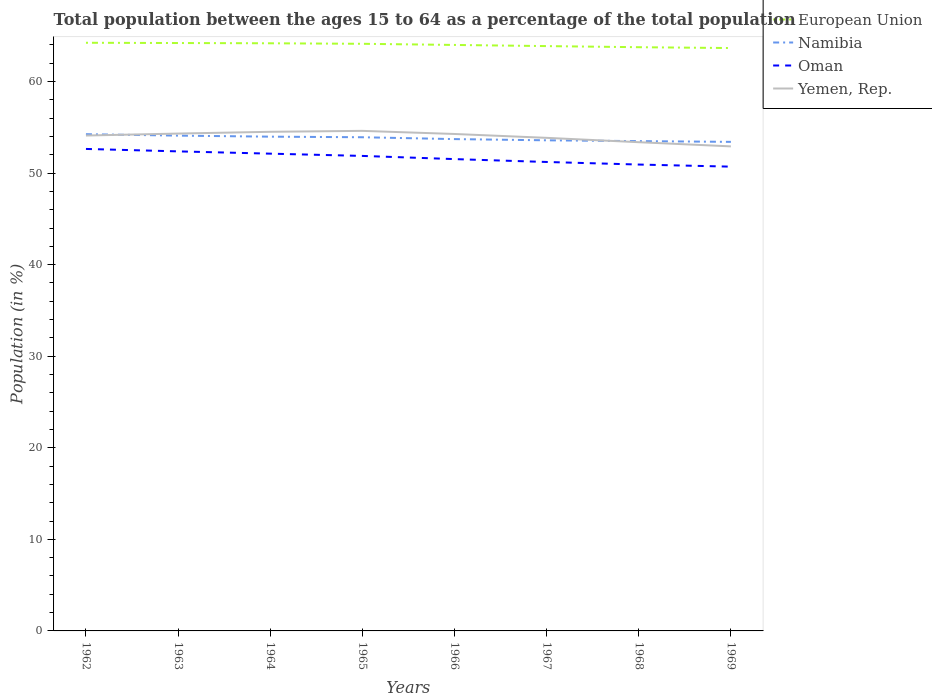How many different coloured lines are there?
Keep it short and to the point. 4. Does the line corresponding to Oman intersect with the line corresponding to Yemen, Rep.?
Make the answer very short. No. Across all years, what is the maximum percentage of the population ages 15 to 64 in Yemen, Rep.?
Your response must be concise. 52.91. In which year was the percentage of the population ages 15 to 64 in Yemen, Rep. maximum?
Offer a very short reply. 1969. What is the total percentage of the population ages 15 to 64 in Yemen, Rep. in the graph?
Your answer should be compact. 1.24. What is the difference between the highest and the second highest percentage of the population ages 15 to 64 in Namibia?
Make the answer very short. 0.84. How many lines are there?
Give a very brief answer. 4. How many years are there in the graph?
Your answer should be very brief. 8. Are the values on the major ticks of Y-axis written in scientific E-notation?
Your response must be concise. No. What is the title of the graph?
Provide a succinct answer. Total population between the ages 15 to 64 as a percentage of the total population. What is the Population (in %) of European Union in 1962?
Your answer should be compact. 64.23. What is the Population (in %) in Namibia in 1962?
Keep it short and to the point. 54.25. What is the Population (in %) of Oman in 1962?
Offer a terse response. 52.63. What is the Population (in %) in Yemen, Rep. in 1962?
Offer a terse response. 54.1. What is the Population (in %) in European Union in 1963?
Keep it short and to the point. 64.2. What is the Population (in %) in Namibia in 1963?
Your response must be concise. 54.09. What is the Population (in %) of Oman in 1963?
Ensure brevity in your answer.  52.37. What is the Population (in %) of Yemen, Rep. in 1963?
Your response must be concise. 54.31. What is the Population (in %) of European Union in 1964?
Your answer should be compact. 64.17. What is the Population (in %) in Namibia in 1964?
Your answer should be very brief. 53.97. What is the Population (in %) of Oman in 1964?
Provide a succinct answer. 52.12. What is the Population (in %) in Yemen, Rep. in 1964?
Your response must be concise. 54.51. What is the Population (in %) of European Union in 1965?
Offer a terse response. 64.12. What is the Population (in %) in Namibia in 1965?
Your answer should be very brief. 53.91. What is the Population (in %) in Oman in 1965?
Offer a terse response. 51.87. What is the Population (in %) in Yemen, Rep. in 1965?
Offer a very short reply. 54.61. What is the Population (in %) of European Union in 1966?
Provide a succinct answer. 63.99. What is the Population (in %) in Namibia in 1966?
Offer a very short reply. 53.71. What is the Population (in %) of Oman in 1966?
Keep it short and to the point. 51.52. What is the Population (in %) in Yemen, Rep. in 1966?
Give a very brief answer. 54.27. What is the Population (in %) in European Union in 1967?
Offer a terse response. 63.86. What is the Population (in %) in Namibia in 1967?
Keep it short and to the point. 53.58. What is the Population (in %) in Oman in 1967?
Provide a short and direct response. 51.21. What is the Population (in %) of Yemen, Rep. in 1967?
Provide a short and direct response. 53.85. What is the Population (in %) in European Union in 1968?
Your answer should be very brief. 63.74. What is the Population (in %) of Namibia in 1968?
Your answer should be very brief. 53.49. What is the Population (in %) in Oman in 1968?
Keep it short and to the point. 50.93. What is the Population (in %) of Yemen, Rep. in 1968?
Offer a very short reply. 53.37. What is the Population (in %) of European Union in 1969?
Provide a short and direct response. 63.65. What is the Population (in %) of Namibia in 1969?
Make the answer very short. 53.41. What is the Population (in %) in Oman in 1969?
Your answer should be very brief. 50.7. What is the Population (in %) in Yemen, Rep. in 1969?
Provide a short and direct response. 52.91. Across all years, what is the maximum Population (in %) in European Union?
Make the answer very short. 64.23. Across all years, what is the maximum Population (in %) of Namibia?
Provide a succinct answer. 54.25. Across all years, what is the maximum Population (in %) in Oman?
Give a very brief answer. 52.63. Across all years, what is the maximum Population (in %) in Yemen, Rep.?
Offer a very short reply. 54.61. Across all years, what is the minimum Population (in %) in European Union?
Offer a very short reply. 63.65. Across all years, what is the minimum Population (in %) of Namibia?
Give a very brief answer. 53.41. Across all years, what is the minimum Population (in %) of Oman?
Provide a succinct answer. 50.7. Across all years, what is the minimum Population (in %) in Yemen, Rep.?
Offer a very short reply. 52.91. What is the total Population (in %) of European Union in the graph?
Provide a short and direct response. 511.96. What is the total Population (in %) of Namibia in the graph?
Your answer should be compact. 430.4. What is the total Population (in %) in Oman in the graph?
Keep it short and to the point. 413.36. What is the total Population (in %) of Yemen, Rep. in the graph?
Your answer should be very brief. 431.92. What is the difference between the Population (in %) in European Union in 1962 and that in 1963?
Make the answer very short. 0.03. What is the difference between the Population (in %) in Namibia in 1962 and that in 1963?
Offer a terse response. 0.16. What is the difference between the Population (in %) of Oman in 1962 and that in 1963?
Your answer should be compact. 0.27. What is the difference between the Population (in %) in Yemen, Rep. in 1962 and that in 1963?
Keep it short and to the point. -0.21. What is the difference between the Population (in %) of European Union in 1962 and that in 1964?
Your answer should be very brief. 0.06. What is the difference between the Population (in %) of Namibia in 1962 and that in 1964?
Your response must be concise. 0.27. What is the difference between the Population (in %) of Oman in 1962 and that in 1964?
Give a very brief answer. 0.52. What is the difference between the Population (in %) in Yemen, Rep. in 1962 and that in 1964?
Your answer should be very brief. -0.41. What is the difference between the Population (in %) of European Union in 1962 and that in 1965?
Ensure brevity in your answer.  0.11. What is the difference between the Population (in %) in Namibia in 1962 and that in 1965?
Keep it short and to the point. 0.33. What is the difference between the Population (in %) of Oman in 1962 and that in 1965?
Keep it short and to the point. 0.76. What is the difference between the Population (in %) of Yemen, Rep. in 1962 and that in 1965?
Offer a terse response. -0.51. What is the difference between the Population (in %) of European Union in 1962 and that in 1966?
Provide a short and direct response. 0.24. What is the difference between the Population (in %) of Namibia in 1962 and that in 1966?
Provide a succinct answer. 0.54. What is the difference between the Population (in %) of Oman in 1962 and that in 1966?
Give a very brief answer. 1.11. What is the difference between the Population (in %) in Yemen, Rep. in 1962 and that in 1966?
Ensure brevity in your answer.  -0.17. What is the difference between the Population (in %) in European Union in 1962 and that in 1967?
Make the answer very short. 0.36. What is the difference between the Population (in %) of Namibia in 1962 and that in 1967?
Give a very brief answer. 0.67. What is the difference between the Population (in %) in Oman in 1962 and that in 1967?
Give a very brief answer. 1.42. What is the difference between the Population (in %) of Yemen, Rep. in 1962 and that in 1967?
Your answer should be compact. 0.25. What is the difference between the Population (in %) in European Union in 1962 and that in 1968?
Your response must be concise. 0.48. What is the difference between the Population (in %) in Namibia in 1962 and that in 1968?
Your answer should be very brief. 0.76. What is the difference between the Population (in %) of Oman in 1962 and that in 1968?
Provide a succinct answer. 1.7. What is the difference between the Population (in %) in Yemen, Rep. in 1962 and that in 1968?
Your response must be concise. 0.73. What is the difference between the Population (in %) in European Union in 1962 and that in 1969?
Give a very brief answer. 0.58. What is the difference between the Population (in %) in Namibia in 1962 and that in 1969?
Your answer should be very brief. 0.84. What is the difference between the Population (in %) of Oman in 1962 and that in 1969?
Provide a succinct answer. 1.93. What is the difference between the Population (in %) in Yemen, Rep. in 1962 and that in 1969?
Offer a very short reply. 1.18. What is the difference between the Population (in %) of European Union in 1963 and that in 1964?
Provide a succinct answer. 0.03. What is the difference between the Population (in %) in Namibia in 1963 and that in 1964?
Your answer should be compact. 0.11. What is the difference between the Population (in %) in Oman in 1963 and that in 1964?
Your answer should be very brief. 0.25. What is the difference between the Population (in %) of Yemen, Rep. in 1963 and that in 1964?
Your response must be concise. -0.19. What is the difference between the Population (in %) in European Union in 1963 and that in 1965?
Provide a succinct answer. 0.08. What is the difference between the Population (in %) in Namibia in 1963 and that in 1965?
Provide a short and direct response. 0.18. What is the difference between the Population (in %) of Oman in 1963 and that in 1965?
Offer a terse response. 0.5. What is the difference between the Population (in %) in Yemen, Rep. in 1963 and that in 1965?
Your response must be concise. -0.3. What is the difference between the Population (in %) of European Union in 1963 and that in 1966?
Keep it short and to the point. 0.21. What is the difference between the Population (in %) in Namibia in 1963 and that in 1966?
Keep it short and to the point. 0.38. What is the difference between the Population (in %) of Oman in 1963 and that in 1966?
Keep it short and to the point. 0.84. What is the difference between the Population (in %) of Yemen, Rep. in 1963 and that in 1966?
Provide a short and direct response. 0.04. What is the difference between the Population (in %) of European Union in 1963 and that in 1967?
Provide a succinct answer. 0.34. What is the difference between the Population (in %) of Namibia in 1963 and that in 1967?
Keep it short and to the point. 0.51. What is the difference between the Population (in %) of Oman in 1963 and that in 1967?
Give a very brief answer. 1.16. What is the difference between the Population (in %) of Yemen, Rep. in 1963 and that in 1967?
Give a very brief answer. 0.47. What is the difference between the Population (in %) of European Union in 1963 and that in 1968?
Give a very brief answer. 0.46. What is the difference between the Population (in %) of Namibia in 1963 and that in 1968?
Your answer should be very brief. 0.6. What is the difference between the Population (in %) of Oman in 1963 and that in 1968?
Provide a succinct answer. 1.44. What is the difference between the Population (in %) in Yemen, Rep. in 1963 and that in 1968?
Give a very brief answer. 0.94. What is the difference between the Population (in %) in European Union in 1963 and that in 1969?
Your answer should be compact. 0.55. What is the difference between the Population (in %) in Namibia in 1963 and that in 1969?
Provide a short and direct response. 0.68. What is the difference between the Population (in %) in Oman in 1963 and that in 1969?
Offer a terse response. 1.67. What is the difference between the Population (in %) of Yemen, Rep. in 1963 and that in 1969?
Offer a very short reply. 1.4. What is the difference between the Population (in %) in European Union in 1964 and that in 1965?
Offer a very short reply. 0.06. What is the difference between the Population (in %) of Namibia in 1964 and that in 1965?
Provide a short and direct response. 0.06. What is the difference between the Population (in %) of Oman in 1964 and that in 1965?
Offer a terse response. 0.25. What is the difference between the Population (in %) of Yemen, Rep. in 1964 and that in 1965?
Your answer should be very brief. -0.1. What is the difference between the Population (in %) of European Union in 1964 and that in 1966?
Provide a succinct answer. 0.18. What is the difference between the Population (in %) in Namibia in 1964 and that in 1966?
Keep it short and to the point. 0.27. What is the difference between the Population (in %) of Oman in 1964 and that in 1966?
Make the answer very short. 0.59. What is the difference between the Population (in %) of Yemen, Rep. in 1964 and that in 1966?
Give a very brief answer. 0.24. What is the difference between the Population (in %) of European Union in 1964 and that in 1967?
Your answer should be very brief. 0.31. What is the difference between the Population (in %) in Namibia in 1964 and that in 1967?
Provide a succinct answer. 0.4. What is the difference between the Population (in %) in Oman in 1964 and that in 1967?
Offer a very short reply. 0.91. What is the difference between the Population (in %) of Yemen, Rep. in 1964 and that in 1967?
Provide a succinct answer. 0.66. What is the difference between the Population (in %) in European Union in 1964 and that in 1968?
Provide a succinct answer. 0.43. What is the difference between the Population (in %) in Namibia in 1964 and that in 1968?
Your response must be concise. 0.49. What is the difference between the Population (in %) in Oman in 1964 and that in 1968?
Keep it short and to the point. 1.19. What is the difference between the Population (in %) in Yemen, Rep. in 1964 and that in 1968?
Give a very brief answer. 1.14. What is the difference between the Population (in %) of European Union in 1964 and that in 1969?
Your answer should be very brief. 0.52. What is the difference between the Population (in %) of Namibia in 1964 and that in 1969?
Give a very brief answer. 0.57. What is the difference between the Population (in %) in Oman in 1964 and that in 1969?
Provide a short and direct response. 1.42. What is the difference between the Population (in %) of Yemen, Rep. in 1964 and that in 1969?
Your answer should be very brief. 1.59. What is the difference between the Population (in %) of European Union in 1965 and that in 1966?
Your answer should be very brief. 0.12. What is the difference between the Population (in %) of Namibia in 1965 and that in 1966?
Your response must be concise. 0.2. What is the difference between the Population (in %) of Oman in 1965 and that in 1966?
Give a very brief answer. 0.35. What is the difference between the Population (in %) of Yemen, Rep. in 1965 and that in 1966?
Offer a terse response. 0.34. What is the difference between the Population (in %) in European Union in 1965 and that in 1967?
Offer a very short reply. 0.25. What is the difference between the Population (in %) of Namibia in 1965 and that in 1967?
Give a very brief answer. 0.33. What is the difference between the Population (in %) in Oman in 1965 and that in 1967?
Your answer should be very brief. 0.66. What is the difference between the Population (in %) in Yemen, Rep. in 1965 and that in 1967?
Your answer should be compact. 0.76. What is the difference between the Population (in %) in European Union in 1965 and that in 1968?
Offer a terse response. 0.37. What is the difference between the Population (in %) in Namibia in 1965 and that in 1968?
Make the answer very short. 0.42. What is the difference between the Population (in %) in Oman in 1965 and that in 1968?
Keep it short and to the point. 0.94. What is the difference between the Population (in %) in Yemen, Rep. in 1965 and that in 1968?
Offer a terse response. 1.24. What is the difference between the Population (in %) of European Union in 1965 and that in 1969?
Give a very brief answer. 0.46. What is the difference between the Population (in %) of Namibia in 1965 and that in 1969?
Provide a short and direct response. 0.5. What is the difference between the Population (in %) in Oman in 1965 and that in 1969?
Give a very brief answer. 1.17. What is the difference between the Population (in %) of Yemen, Rep. in 1965 and that in 1969?
Your answer should be very brief. 1.69. What is the difference between the Population (in %) in European Union in 1966 and that in 1967?
Provide a short and direct response. 0.13. What is the difference between the Population (in %) of Namibia in 1966 and that in 1967?
Keep it short and to the point. 0.13. What is the difference between the Population (in %) of Oman in 1966 and that in 1967?
Offer a very short reply. 0.31. What is the difference between the Population (in %) in Yemen, Rep. in 1966 and that in 1967?
Give a very brief answer. 0.42. What is the difference between the Population (in %) in European Union in 1966 and that in 1968?
Keep it short and to the point. 0.25. What is the difference between the Population (in %) of Namibia in 1966 and that in 1968?
Your response must be concise. 0.22. What is the difference between the Population (in %) in Oman in 1966 and that in 1968?
Your response must be concise. 0.59. What is the difference between the Population (in %) of Yemen, Rep. in 1966 and that in 1968?
Your answer should be compact. 0.9. What is the difference between the Population (in %) of European Union in 1966 and that in 1969?
Your answer should be compact. 0.34. What is the difference between the Population (in %) in Namibia in 1966 and that in 1969?
Provide a succinct answer. 0.3. What is the difference between the Population (in %) in Oman in 1966 and that in 1969?
Your answer should be compact. 0.82. What is the difference between the Population (in %) in Yemen, Rep. in 1966 and that in 1969?
Your answer should be compact. 1.35. What is the difference between the Population (in %) of European Union in 1967 and that in 1968?
Provide a short and direct response. 0.12. What is the difference between the Population (in %) in Namibia in 1967 and that in 1968?
Make the answer very short. 0.09. What is the difference between the Population (in %) in Oman in 1967 and that in 1968?
Offer a very short reply. 0.28. What is the difference between the Population (in %) in Yemen, Rep. in 1967 and that in 1968?
Your answer should be very brief. 0.48. What is the difference between the Population (in %) of European Union in 1967 and that in 1969?
Your response must be concise. 0.21. What is the difference between the Population (in %) in Namibia in 1967 and that in 1969?
Offer a terse response. 0.17. What is the difference between the Population (in %) in Oman in 1967 and that in 1969?
Make the answer very short. 0.51. What is the difference between the Population (in %) of Yemen, Rep. in 1967 and that in 1969?
Keep it short and to the point. 0.93. What is the difference between the Population (in %) of European Union in 1968 and that in 1969?
Provide a succinct answer. 0.09. What is the difference between the Population (in %) of Namibia in 1968 and that in 1969?
Offer a terse response. 0.08. What is the difference between the Population (in %) of Oman in 1968 and that in 1969?
Keep it short and to the point. 0.23. What is the difference between the Population (in %) in Yemen, Rep. in 1968 and that in 1969?
Your response must be concise. 0.46. What is the difference between the Population (in %) in European Union in 1962 and the Population (in %) in Namibia in 1963?
Ensure brevity in your answer.  10.14. What is the difference between the Population (in %) of European Union in 1962 and the Population (in %) of Oman in 1963?
Your response must be concise. 11.86. What is the difference between the Population (in %) in European Union in 1962 and the Population (in %) in Yemen, Rep. in 1963?
Offer a terse response. 9.92. What is the difference between the Population (in %) in Namibia in 1962 and the Population (in %) in Oman in 1963?
Provide a succinct answer. 1.88. What is the difference between the Population (in %) in Namibia in 1962 and the Population (in %) in Yemen, Rep. in 1963?
Your answer should be compact. -0.07. What is the difference between the Population (in %) of Oman in 1962 and the Population (in %) of Yemen, Rep. in 1963?
Offer a terse response. -1.68. What is the difference between the Population (in %) of European Union in 1962 and the Population (in %) of Namibia in 1964?
Keep it short and to the point. 10.25. What is the difference between the Population (in %) of European Union in 1962 and the Population (in %) of Oman in 1964?
Provide a short and direct response. 12.11. What is the difference between the Population (in %) in European Union in 1962 and the Population (in %) in Yemen, Rep. in 1964?
Provide a succinct answer. 9.72. What is the difference between the Population (in %) in Namibia in 1962 and the Population (in %) in Oman in 1964?
Your answer should be compact. 2.13. What is the difference between the Population (in %) in Namibia in 1962 and the Population (in %) in Yemen, Rep. in 1964?
Provide a short and direct response. -0.26. What is the difference between the Population (in %) of Oman in 1962 and the Population (in %) of Yemen, Rep. in 1964?
Provide a short and direct response. -1.87. What is the difference between the Population (in %) of European Union in 1962 and the Population (in %) of Namibia in 1965?
Provide a succinct answer. 10.32. What is the difference between the Population (in %) in European Union in 1962 and the Population (in %) in Oman in 1965?
Your response must be concise. 12.36. What is the difference between the Population (in %) of European Union in 1962 and the Population (in %) of Yemen, Rep. in 1965?
Ensure brevity in your answer.  9.62. What is the difference between the Population (in %) in Namibia in 1962 and the Population (in %) in Oman in 1965?
Ensure brevity in your answer.  2.37. What is the difference between the Population (in %) of Namibia in 1962 and the Population (in %) of Yemen, Rep. in 1965?
Your answer should be compact. -0.36. What is the difference between the Population (in %) of Oman in 1962 and the Population (in %) of Yemen, Rep. in 1965?
Your answer should be compact. -1.97. What is the difference between the Population (in %) in European Union in 1962 and the Population (in %) in Namibia in 1966?
Give a very brief answer. 10.52. What is the difference between the Population (in %) of European Union in 1962 and the Population (in %) of Oman in 1966?
Provide a short and direct response. 12.7. What is the difference between the Population (in %) of European Union in 1962 and the Population (in %) of Yemen, Rep. in 1966?
Give a very brief answer. 9.96. What is the difference between the Population (in %) of Namibia in 1962 and the Population (in %) of Oman in 1966?
Give a very brief answer. 2.72. What is the difference between the Population (in %) in Namibia in 1962 and the Population (in %) in Yemen, Rep. in 1966?
Your answer should be compact. -0.02. What is the difference between the Population (in %) in Oman in 1962 and the Population (in %) in Yemen, Rep. in 1966?
Your response must be concise. -1.63. What is the difference between the Population (in %) in European Union in 1962 and the Population (in %) in Namibia in 1967?
Provide a short and direct response. 10.65. What is the difference between the Population (in %) in European Union in 1962 and the Population (in %) in Oman in 1967?
Give a very brief answer. 13.02. What is the difference between the Population (in %) of European Union in 1962 and the Population (in %) of Yemen, Rep. in 1967?
Keep it short and to the point. 10.38. What is the difference between the Population (in %) in Namibia in 1962 and the Population (in %) in Oman in 1967?
Offer a terse response. 3.04. What is the difference between the Population (in %) in Namibia in 1962 and the Population (in %) in Yemen, Rep. in 1967?
Keep it short and to the point. 0.4. What is the difference between the Population (in %) in Oman in 1962 and the Population (in %) in Yemen, Rep. in 1967?
Ensure brevity in your answer.  -1.21. What is the difference between the Population (in %) of European Union in 1962 and the Population (in %) of Namibia in 1968?
Your answer should be compact. 10.74. What is the difference between the Population (in %) in European Union in 1962 and the Population (in %) in Oman in 1968?
Make the answer very short. 13.3. What is the difference between the Population (in %) in European Union in 1962 and the Population (in %) in Yemen, Rep. in 1968?
Your response must be concise. 10.86. What is the difference between the Population (in %) of Namibia in 1962 and the Population (in %) of Oman in 1968?
Provide a short and direct response. 3.32. What is the difference between the Population (in %) of Namibia in 1962 and the Population (in %) of Yemen, Rep. in 1968?
Provide a short and direct response. 0.88. What is the difference between the Population (in %) in Oman in 1962 and the Population (in %) in Yemen, Rep. in 1968?
Keep it short and to the point. -0.74. What is the difference between the Population (in %) in European Union in 1962 and the Population (in %) in Namibia in 1969?
Provide a succinct answer. 10.82. What is the difference between the Population (in %) of European Union in 1962 and the Population (in %) of Oman in 1969?
Your answer should be compact. 13.53. What is the difference between the Population (in %) of European Union in 1962 and the Population (in %) of Yemen, Rep. in 1969?
Keep it short and to the point. 11.31. What is the difference between the Population (in %) of Namibia in 1962 and the Population (in %) of Oman in 1969?
Ensure brevity in your answer.  3.55. What is the difference between the Population (in %) of Namibia in 1962 and the Population (in %) of Yemen, Rep. in 1969?
Offer a very short reply. 1.33. What is the difference between the Population (in %) in Oman in 1962 and the Population (in %) in Yemen, Rep. in 1969?
Provide a short and direct response. -0.28. What is the difference between the Population (in %) of European Union in 1963 and the Population (in %) of Namibia in 1964?
Your answer should be compact. 10.23. What is the difference between the Population (in %) of European Union in 1963 and the Population (in %) of Oman in 1964?
Your response must be concise. 12.08. What is the difference between the Population (in %) of European Union in 1963 and the Population (in %) of Yemen, Rep. in 1964?
Give a very brief answer. 9.69. What is the difference between the Population (in %) of Namibia in 1963 and the Population (in %) of Oman in 1964?
Your response must be concise. 1.97. What is the difference between the Population (in %) of Namibia in 1963 and the Population (in %) of Yemen, Rep. in 1964?
Offer a very short reply. -0.42. What is the difference between the Population (in %) of Oman in 1963 and the Population (in %) of Yemen, Rep. in 1964?
Ensure brevity in your answer.  -2.14. What is the difference between the Population (in %) in European Union in 1963 and the Population (in %) in Namibia in 1965?
Ensure brevity in your answer.  10.29. What is the difference between the Population (in %) of European Union in 1963 and the Population (in %) of Oman in 1965?
Offer a terse response. 12.33. What is the difference between the Population (in %) in European Union in 1963 and the Population (in %) in Yemen, Rep. in 1965?
Ensure brevity in your answer.  9.59. What is the difference between the Population (in %) of Namibia in 1963 and the Population (in %) of Oman in 1965?
Offer a terse response. 2.22. What is the difference between the Population (in %) in Namibia in 1963 and the Population (in %) in Yemen, Rep. in 1965?
Give a very brief answer. -0.52. What is the difference between the Population (in %) of Oman in 1963 and the Population (in %) of Yemen, Rep. in 1965?
Keep it short and to the point. -2.24. What is the difference between the Population (in %) of European Union in 1963 and the Population (in %) of Namibia in 1966?
Your response must be concise. 10.49. What is the difference between the Population (in %) of European Union in 1963 and the Population (in %) of Oman in 1966?
Your answer should be very brief. 12.68. What is the difference between the Population (in %) in European Union in 1963 and the Population (in %) in Yemen, Rep. in 1966?
Make the answer very short. 9.93. What is the difference between the Population (in %) of Namibia in 1963 and the Population (in %) of Oman in 1966?
Your response must be concise. 2.56. What is the difference between the Population (in %) of Namibia in 1963 and the Population (in %) of Yemen, Rep. in 1966?
Your response must be concise. -0.18. What is the difference between the Population (in %) in Oman in 1963 and the Population (in %) in Yemen, Rep. in 1966?
Make the answer very short. -1.9. What is the difference between the Population (in %) of European Union in 1963 and the Population (in %) of Namibia in 1967?
Provide a short and direct response. 10.62. What is the difference between the Population (in %) of European Union in 1963 and the Population (in %) of Oman in 1967?
Make the answer very short. 12.99. What is the difference between the Population (in %) of European Union in 1963 and the Population (in %) of Yemen, Rep. in 1967?
Provide a short and direct response. 10.35. What is the difference between the Population (in %) of Namibia in 1963 and the Population (in %) of Oman in 1967?
Offer a very short reply. 2.88. What is the difference between the Population (in %) in Namibia in 1963 and the Population (in %) in Yemen, Rep. in 1967?
Give a very brief answer. 0.24. What is the difference between the Population (in %) of Oman in 1963 and the Population (in %) of Yemen, Rep. in 1967?
Offer a terse response. -1.48. What is the difference between the Population (in %) of European Union in 1963 and the Population (in %) of Namibia in 1968?
Provide a short and direct response. 10.71. What is the difference between the Population (in %) of European Union in 1963 and the Population (in %) of Oman in 1968?
Your response must be concise. 13.27. What is the difference between the Population (in %) of European Union in 1963 and the Population (in %) of Yemen, Rep. in 1968?
Provide a succinct answer. 10.83. What is the difference between the Population (in %) of Namibia in 1963 and the Population (in %) of Oman in 1968?
Provide a succinct answer. 3.16. What is the difference between the Population (in %) in Namibia in 1963 and the Population (in %) in Yemen, Rep. in 1968?
Offer a very short reply. 0.72. What is the difference between the Population (in %) of Oman in 1963 and the Population (in %) of Yemen, Rep. in 1968?
Make the answer very short. -1. What is the difference between the Population (in %) in European Union in 1963 and the Population (in %) in Namibia in 1969?
Provide a succinct answer. 10.79. What is the difference between the Population (in %) of European Union in 1963 and the Population (in %) of Oman in 1969?
Your answer should be very brief. 13.5. What is the difference between the Population (in %) of European Union in 1963 and the Population (in %) of Yemen, Rep. in 1969?
Offer a very short reply. 11.29. What is the difference between the Population (in %) of Namibia in 1963 and the Population (in %) of Oman in 1969?
Your answer should be compact. 3.39. What is the difference between the Population (in %) in Namibia in 1963 and the Population (in %) in Yemen, Rep. in 1969?
Offer a very short reply. 1.17. What is the difference between the Population (in %) in Oman in 1963 and the Population (in %) in Yemen, Rep. in 1969?
Keep it short and to the point. -0.55. What is the difference between the Population (in %) in European Union in 1964 and the Population (in %) in Namibia in 1965?
Offer a terse response. 10.26. What is the difference between the Population (in %) of European Union in 1964 and the Population (in %) of Oman in 1965?
Offer a terse response. 12.3. What is the difference between the Population (in %) of European Union in 1964 and the Population (in %) of Yemen, Rep. in 1965?
Your answer should be very brief. 9.56. What is the difference between the Population (in %) of Namibia in 1964 and the Population (in %) of Oman in 1965?
Provide a short and direct response. 2.1. What is the difference between the Population (in %) in Namibia in 1964 and the Population (in %) in Yemen, Rep. in 1965?
Your response must be concise. -0.63. What is the difference between the Population (in %) of Oman in 1964 and the Population (in %) of Yemen, Rep. in 1965?
Offer a very short reply. -2.49. What is the difference between the Population (in %) in European Union in 1964 and the Population (in %) in Namibia in 1966?
Your answer should be compact. 10.46. What is the difference between the Population (in %) in European Union in 1964 and the Population (in %) in Oman in 1966?
Keep it short and to the point. 12.65. What is the difference between the Population (in %) in European Union in 1964 and the Population (in %) in Yemen, Rep. in 1966?
Give a very brief answer. 9.9. What is the difference between the Population (in %) in Namibia in 1964 and the Population (in %) in Oman in 1966?
Provide a short and direct response. 2.45. What is the difference between the Population (in %) of Namibia in 1964 and the Population (in %) of Yemen, Rep. in 1966?
Your answer should be very brief. -0.29. What is the difference between the Population (in %) in Oman in 1964 and the Population (in %) in Yemen, Rep. in 1966?
Your response must be concise. -2.15. What is the difference between the Population (in %) in European Union in 1964 and the Population (in %) in Namibia in 1967?
Keep it short and to the point. 10.6. What is the difference between the Population (in %) in European Union in 1964 and the Population (in %) in Oman in 1967?
Give a very brief answer. 12.96. What is the difference between the Population (in %) in European Union in 1964 and the Population (in %) in Yemen, Rep. in 1967?
Keep it short and to the point. 10.33. What is the difference between the Population (in %) of Namibia in 1964 and the Population (in %) of Oman in 1967?
Your answer should be compact. 2.76. What is the difference between the Population (in %) in Namibia in 1964 and the Population (in %) in Yemen, Rep. in 1967?
Provide a short and direct response. 0.13. What is the difference between the Population (in %) in Oman in 1964 and the Population (in %) in Yemen, Rep. in 1967?
Your response must be concise. -1.73. What is the difference between the Population (in %) of European Union in 1964 and the Population (in %) of Namibia in 1968?
Give a very brief answer. 10.68. What is the difference between the Population (in %) of European Union in 1964 and the Population (in %) of Oman in 1968?
Your response must be concise. 13.24. What is the difference between the Population (in %) in European Union in 1964 and the Population (in %) in Yemen, Rep. in 1968?
Ensure brevity in your answer.  10.8. What is the difference between the Population (in %) in Namibia in 1964 and the Population (in %) in Oman in 1968?
Give a very brief answer. 3.04. What is the difference between the Population (in %) in Namibia in 1964 and the Population (in %) in Yemen, Rep. in 1968?
Offer a very short reply. 0.6. What is the difference between the Population (in %) of Oman in 1964 and the Population (in %) of Yemen, Rep. in 1968?
Make the answer very short. -1.25. What is the difference between the Population (in %) in European Union in 1964 and the Population (in %) in Namibia in 1969?
Provide a succinct answer. 10.77. What is the difference between the Population (in %) of European Union in 1964 and the Population (in %) of Oman in 1969?
Your answer should be very brief. 13.47. What is the difference between the Population (in %) of European Union in 1964 and the Population (in %) of Yemen, Rep. in 1969?
Ensure brevity in your answer.  11.26. What is the difference between the Population (in %) in Namibia in 1964 and the Population (in %) in Oman in 1969?
Keep it short and to the point. 3.27. What is the difference between the Population (in %) in Namibia in 1964 and the Population (in %) in Yemen, Rep. in 1969?
Offer a terse response. 1.06. What is the difference between the Population (in %) in Oman in 1964 and the Population (in %) in Yemen, Rep. in 1969?
Your response must be concise. -0.8. What is the difference between the Population (in %) in European Union in 1965 and the Population (in %) in Namibia in 1966?
Your answer should be very brief. 10.41. What is the difference between the Population (in %) of European Union in 1965 and the Population (in %) of Oman in 1966?
Your answer should be very brief. 12.59. What is the difference between the Population (in %) in European Union in 1965 and the Population (in %) in Yemen, Rep. in 1966?
Give a very brief answer. 9.85. What is the difference between the Population (in %) of Namibia in 1965 and the Population (in %) of Oman in 1966?
Your response must be concise. 2.39. What is the difference between the Population (in %) of Namibia in 1965 and the Population (in %) of Yemen, Rep. in 1966?
Your response must be concise. -0.36. What is the difference between the Population (in %) in Oman in 1965 and the Population (in %) in Yemen, Rep. in 1966?
Keep it short and to the point. -2.4. What is the difference between the Population (in %) in European Union in 1965 and the Population (in %) in Namibia in 1967?
Offer a terse response. 10.54. What is the difference between the Population (in %) in European Union in 1965 and the Population (in %) in Oman in 1967?
Offer a terse response. 12.9. What is the difference between the Population (in %) of European Union in 1965 and the Population (in %) of Yemen, Rep. in 1967?
Give a very brief answer. 10.27. What is the difference between the Population (in %) of Namibia in 1965 and the Population (in %) of Oman in 1967?
Make the answer very short. 2.7. What is the difference between the Population (in %) in Namibia in 1965 and the Population (in %) in Yemen, Rep. in 1967?
Give a very brief answer. 0.06. What is the difference between the Population (in %) in Oman in 1965 and the Population (in %) in Yemen, Rep. in 1967?
Offer a terse response. -1.97. What is the difference between the Population (in %) in European Union in 1965 and the Population (in %) in Namibia in 1968?
Provide a succinct answer. 10.63. What is the difference between the Population (in %) of European Union in 1965 and the Population (in %) of Oman in 1968?
Offer a terse response. 13.19. What is the difference between the Population (in %) of European Union in 1965 and the Population (in %) of Yemen, Rep. in 1968?
Ensure brevity in your answer.  10.75. What is the difference between the Population (in %) in Namibia in 1965 and the Population (in %) in Oman in 1968?
Give a very brief answer. 2.98. What is the difference between the Population (in %) of Namibia in 1965 and the Population (in %) of Yemen, Rep. in 1968?
Provide a succinct answer. 0.54. What is the difference between the Population (in %) in Oman in 1965 and the Population (in %) in Yemen, Rep. in 1968?
Offer a terse response. -1.5. What is the difference between the Population (in %) in European Union in 1965 and the Population (in %) in Namibia in 1969?
Offer a very short reply. 10.71. What is the difference between the Population (in %) in European Union in 1965 and the Population (in %) in Oman in 1969?
Keep it short and to the point. 13.42. What is the difference between the Population (in %) in European Union in 1965 and the Population (in %) in Yemen, Rep. in 1969?
Keep it short and to the point. 11.2. What is the difference between the Population (in %) of Namibia in 1965 and the Population (in %) of Oman in 1969?
Offer a very short reply. 3.21. What is the difference between the Population (in %) of Oman in 1965 and the Population (in %) of Yemen, Rep. in 1969?
Ensure brevity in your answer.  -1.04. What is the difference between the Population (in %) of European Union in 1966 and the Population (in %) of Namibia in 1967?
Offer a very short reply. 10.41. What is the difference between the Population (in %) in European Union in 1966 and the Population (in %) in Oman in 1967?
Give a very brief answer. 12.78. What is the difference between the Population (in %) in European Union in 1966 and the Population (in %) in Yemen, Rep. in 1967?
Offer a terse response. 10.14. What is the difference between the Population (in %) in Namibia in 1966 and the Population (in %) in Oman in 1967?
Your response must be concise. 2.5. What is the difference between the Population (in %) of Namibia in 1966 and the Population (in %) of Yemen, Rep. in 1967?
Provide a succinct answer. -0.14. What is the difference between the Population (in %) of Oman in 1966 and the Population (in %) of Yemen, Rep. in 1967?
Make the answer very short. -2.32. What is the difference between the Population (in %) in European Union in 1966 and the Population (in %) in Namibia in 1968?
Make the answer very short. 10.5. What is the difference between the Population (in %) of European Union in 1966 and the Population (in %) of Oman in 1968?
Make the answer very short. 13.06. What is the difference between the Population (in %) of European Union in 1966 and the Population (in %) of Yemen, Rep. in 1968?
Ensure brevity in your answer.  10.62. What is the difference between the Population (in %) of Namibia in 1966 and the Population (in %) of Oman in 1968?
Make the answer very short. 2.78. What is the difference between the Population (in %) of Namibia in 1966 and the Population (in %) of Yemen, Rep. in 1968?
Offer a terse response. 0.34. What is the difference between the Population (in %) in Oman in 1966 and the Population (in %) in Yemen, Rep. in 1968?
Make the answer very short. -1.85. What is the difference between the Population (in %) of European Union in 1966 and the Population (in %) of Namibia in 1969?
Provide a succinct answer. 10.58. What is the difference between the Population (in %) of European Union in 1966 and the Population (in %) of Oman in 1969?
Make the answer very short. 13.29. What is the difference between the Population (in %) of European Union in 1966 and the Population (in %) of Yemen, Rep. in 1969?
Ensure brevity in your answer.  11.08. What is the difference between the Population (in %) in Namibia in 1966 and the Population (in %) in Oman in 1969?
Provide a succinct answer. 3.01. What is the difference between the Population (in %) of Namibia in 1966 and the Population (in %) of Yemen, Rep. in 1969?
Your response must be concise. 0.79. What is the difference between the Population (in %) of Oman in 1966 and the Population (in %) of Yemen, Rep. in 1969?
Provide a succinct answer. -1.39. What is the difference between the Population (in %) in European Union in 1967 and the Population (in %) in Namibia in 1968?
Provide a short and direct response. 10.38. What is the difference between the Population (in %) in European Union in 1967 and the Population (in %) in Oman in 1968?
Ensure brevity in your answer.  12.93. What is the difference between the Population (in %) of European Union in 1967 and the Population (in %) of Yemen, Rep. in 1968?
Your answer should be compact. 10.49. What is the difference between the Population (in %) of Namibia in 1967 and the Population (in %) of Oman in 1968?
Your answer should be very brief. 2.65. What is the difference between the Population (in %) of Namibia in 1967 and the Population (in %) of Yemen, Rep. in 1968?
Your response must be concise. 0.21. What is the difference between the Population (in %) in Oman in 1967 and the Population (in %) in Yemen, Rep. in 1968?
Make the answer very short. -2.16. What is the difference between the Population (in %) in European Union in 1967 and the Population (in %) in Namibia in 1969?
Offer a very short reply. 10.46. What is the difference between the Population (in %) in European Union in 1967 and the Population (in %) in Oman in 1969?
Your response must be concise. 13.16. What is the difference between the Population (in %) in European Union in 1967 and the Population (in %) in Yemen, Rep. in 1969?
Make the answer very short. 10.95. What is the difference between the Population (in %) of Namibia in 1967 and the Population (in %) of Oman in 1969?
Keep it short and to the point. 2.88. What is the difference between the Population (in %) in Namibia in 1967 and the Population (in %) in Yemen, Rep. in 1969?
Give a very brief answer. 0.66. What is the difference between the Population (in %) of Oman in 1967 and the Population (in %) of Yemen, Rep. in 1969?
Keep it short and to the point. -1.7. What is the difference between the Population (in %) of European Union in 1968 and the Population (in %) of Namibia in 1969?
Keep it short and to the point. 10.34. What is the difference between the Population (in %) in European Union in 1968 and the Population (in %) in Oman in 1969?
Ensure brevity in your answer.  13.04. What is the difference between the Population (in %) of European Union in 1968 and the Population (in %) of Yemen, Rep. in 1969?
Your answer should be compact. 10.83. What is the difference between the Population (in %) of Namibia in 1968 and the Population (in %) of Oman in 1969?
Offer a very short reply. 2.79. What is the difference between the Population (in %) of Namibia in 1968 and the Population (in %) of Yemen, Rep. in 1969?
Keep it short and to the point. 0.57. What is the difference between the Population (in %) in Oman in 1968 and the Population (in %) in Yemen, Rep. in 1969?
Provide a short and direct response. -1.98. What is the average Population (in %) of European Union per year?
Your answer should be compact. 64. What is the average Population (in %) of Namibia per year?
Your answer should be compact. 53.8. What is the average Population (in %) in Oman per year?
Offer a very short reply. 51.67. What is the average Population (in %) in Yemen, Rep. per year?
Ensure brevity in your answer.  53.99. In the year 1962, what is the difference between the Population (in %) in European Union and Population (in %) in Namibia?
Your answer should be very brief. 9.98. In the year 1962, what is the difference between the Population (in %) of European Union and Population (in %) of Oman?
Ensure brevity in your answer.  11.59. In the year 1962, what is the difference between the Population (in %) in European Union and Population (in %) in Yemen, Rep.?
Make the answer very short. 10.13. In the year 1962, what is the difference between the Population (in %) of Namibia and Population (in %) of Oman?
Your response must be concise. 1.61. In the year 1962, what is the difference between the Population (in %) in Namibia and Population (in %) in Yemen, Rep.?
Ensure brevity in your answer.  0.15. In the year 1962, what is the difference between the Population (in %) of Oman and Population (in %) of Yemen, Rep.?
Make the answer very short. -1.46. In the year 1963, what is the difference between the Population (in %) of European Union and Population (in %) of Namibia?
Your answer should be compact. 10.11. In the year 1963, what is the difference between the Population (in %) in European Union and Population (in %) in Oman?
Keep it short and to the point. 11.83. In the year 1963, what is the difference between the Population (in %) of European Union and Population (in %) of Yemen, Rep.?
Offer a very short reply. 9.89. In the year 1963, what is the difference between the Population (in %) of Namibia and Population (in %) of Oman?
Provide a succinct answer. 1.72. In the year 1963, what is the difference between the Population (in %) in Namibia and Population (in %) in Yemen, Rep.?
Give a very brief answer. -0.23. In the year 1963, what is the difference between the Population (in %) of Oman and Population (in %) of Yemen, Rep.?
Keep it short and to the point. -1.94. In the year 1964, what is the difference between the Population (in %) in European Union and Population (in %) in Namibia?
Give a very brief answer. 10.2. In the year 1964, what is the difference between the Population (in %) in European Union and Population (in %) in Oman?
Keep it short and to the point. 12.05. In the year 1964, what is the difference between the Population (in %) of European Union and Population (in %) of Yemen, Rep.?
Offer a very short reply. 9.67. In the year 1964, what is the difference between the Population (in %) in Namibia and Population (in %) in Oman?
Keep it short and to the point. 1.86. In the year 1964, what is the difference between the Population (in %) of Namibia and Population (in %) of Yemen, Rep.?
Your answer should be very brief. -0.53. In the year 1964, what is the difference between the Population (in %) of Oman and Population (in %) of Yemen, Rep.?
Give a very brief answer. -2.39. In the year 1965, what is the difference between the Population (in %) in European Union and Population (in %) in Namibia?
Make the answer very short. 10.2. In the year 1965, what is the difference between the Population (in %) of European Union and Population (in %) of Oman?
Offer a terse response. 12.24. In the year 1965, what is the difference between the Population (in %) of European Union and Population (in %) of Yemen, Rep.?
Your answer should be very brief. 9.51. In the year 1965, what is the difference between the Population (in %) of Namibia and Population (in %) of Oman?
Provide a short and direct response. 2.04. In the year 1965, what is the difference between the Population (in %) in Namibia and Population (in %) in Yemen, Rep.?
Give a very brief answer. -0.7. In the year 1965, what is the difference between the Population (in %) of Oman and Population (in %) of Yemen, Rep.?
Offer a terse response. -2.74. In the year 1966, what is the difference between the Population (in %) of European Union and Population (in %) of Namibia?
Your answer should be compact. 10.28. In the year 1966, what is the difference between the Population (in %) of European Union and Population (in %) of Oman?
Offer a terse response. 12.47. In the year 1966, what is the difference between the Population (in %) in European Union and Population (in %) in Yemen, Rep.?
Your answer should be compact. 9.72. In the year 1966, what is the difference between the Population (in %) of Namibia and Population (in %) of Oman?
Your answer should be very brief. 2.18. In the year 1966, what is the difference between the Population (in %) in Namibia and Population (in %) in Yemen, Rep.?
Your answer should be very brief. -0.56. In the year 1966, what is the difference between the Population (in %) of Oman and Population (in %) of Yemen, Rep.?
Provide a short and direct response. -2.74. In the year 1967, what is the difference between the Population (in %) in European Union and Population (in %) in Namibia?
Offer a terse response. 10.29. In the year 1967, what is the difference between the Population (in %) of European Union and Population (in %) of Oman?
Make the answer very short. 12.65. In the year 1967, what is the difference between the Population (in %) of European Union and Population (in %) of Yemen, Rep.?
Give a very brief answer. 10.02. In the year 1967, what is the difference between the Population (in %) in Namibia and Population (in %) in Oman?
Make the answer very short. 2.37. In the year 1967, what is the difference between the Population (in %) in Namibia and Population (in %) in Yemen, Rep.?
Your answer should be compact. -0.27. In the year 1967, what is the difference between the Population (in %) of Oman and Population (in %) of Yemen, Rep.?
Provide a short and direct response. -2.64. In the year 1968, what is the difference between the Population (in %) of European Union and Population (in %) of Namibia?
Your response must be concise. 10.26. In the year 1968, what is the difference between the Population (in %) of European Union and Population (in %) of Oman?
Provide a succinct answer. 12.81. In the year 1968, what is the difference between the Population (in %) of European Union and Population (in %) of Yemen, Rep.?
Ensure brevity in your answer.  10.37. In the year 1968, what is the difference between the Population (in %) in Namibia and Population (in %) in Oman?
Your response must be concise. 2.56. In the year 1968, what is the difference between the Population (in %) of Namibia and Population (in %) of Yemen, Rep.?
Offer a terse response. 0.12. In the year 1968, what is the difference between the Population (in %) in Oman and Population (in %) in Yemen, Rep.?
Offer a very short reply. -2.44. In the year 1969, what is the difference between the Population (in %) of European Union and Population (in %) of Namibia?
Your answer should be very brief. 10.24. In the year 1969, what is the difference between the Population (in %) of European Union and Population (in %) of Oman?
Make the answer very short. 12.95. In the year 1969, what is the difference between the Population (in %) in European Union and Population (in %) in Yemen, Rep.?
Offer a terse response. 10.74. In the year 1969, what is the difference between the Population (in %) in Namibia and Population (in %) in Oman?
Your answer should be very brief. 2.71. In the year 1969, what is the difference between the Population (in %) of Namibia and Population (in %) of Yemen, Rep.?
Keep it short and to the point. 0.49. In the year 1969, what is the difference between the Population (in %) in Oman and Population (in %) in Yemen, Rep.?
Your answer should be compact. -2.21. What is the ratio of the Population (in %) in Oman in 1962 to that in 1964?
Your answer should be very brief. 1.01. What is the ratio of the Population (in %) of Yemen, Rep. in 1962 to that in 1964?
Provide a short and direct response. 0.99. What is the ratio of the Population (in %) of Oman in 1962 to that in 1965?
Your response must be concise. 1.01. What is the ratio of the Population (in %) of Namibia in 1962 to that in 1966?
Ensure brevity in your answer.  1.01. What is the ratio of the Population (in %) of Oman in 1962 to that in 1966?
Your answer should be very brief. 1.02. What is the ratio of the Population (in %) in Yemen, Rep. in 1962 to that in 1966?
Give a very brief answer. 1. What is the ratio of the Population (in %) of Namibia in 1962 to that in 1967?
Your answer should be very brief. 1.01. What is the ratio of the Population (in %) in Oman in 1962 to that in 1967?
Provide a short and direct response. 1.03. What is the ratio of the Population (in %) in Yemen, Rep. in 1962 to that in 1967?
Your response must be concise. 1. What is the ratio of the Population (in %) in European Union in 1962 to that in 1968?
Offer a very short reply. 1.01. What is the ratio of the Population (in %) of Namibia in 1962 to that in 1968?
Ensure brevity in your answer.  1.01. What is the ratio of the Population (in %) in Oman in 1962 to that in 1968?
Your answer should be very brief. 1.03. What is the ratio of the Population (in %) in Yemen, Rep. in 1962 to that in 1968?
Offer a very short reply. 1.01. What is the ratio of the Population (in %) in European Union in 1962 to that in 1969?
Keep it short and to the point. 1.01. What is the ratio of the Population (in %) of Namibia in 1962 to that in 1969?
Your response must be concise. 1.02. What is the ratio of the Population (in %) of Oman in 1962 to that in 1969?
Make the answer very short. 1.04. What is the ratio of the Population (in %) in Yemen, Rep. in 1962 to that in 1969?
Your response must be concise. 1.02. What is the ratio of the Population (in %) in Oman in 1963 to that in 1964?
Give a very brief answer. 1. What is the ratio of the Population (in %) in Yemen, Rep. in 1963 to that in 1964?
Offer a very short reply. 1. What is the ratio of the Population (in %) in Oman in 1963 to that in 1965?
Offer a very short reply. 1.01. What is the ratio of the Population (in %) of European Union in 1963 to that in 1966?
Make the answer very short. 1. What is the ratio of the Population (in %) in Namibia in 1963 to that in 1966?
Ensure brevity in your answer.  1.01. What is the ratio of the Population (in %) of Oman in 1963 to that in 1966?
Provide a short and direct response. 1.02. What is the ratio of the Population (in %) of Namibia in 1963 to that in 1967?
Provide a succinct answer. 1.01. What is the ratio of the Population (in %) in Oman in 1963 to that in 1967?
Make the answer very short. 1.02. What is the ratio of the Population (in %) of Yemen, Rep. in 1963 to that in 1967?
Your answer should be compact. 1.01. What is the ratio of the Population (in %) of European Union in 1963 to that in 1968?
Your answer should be compact. 1.01. What is the ratio of the Population (in %) in Namibia in 1963 to that in 1968?
Provide a short and direct response. 1.01. What is the ratio of the Population (in %) in Oman in 1963 to that in 1968?
Offer a terse response. 1.03. What is the ratio of the Population (in %) in Yemen, Rep. in 1963 to that in 1968?
Make the answer very short. 1.02. What is the ratio of the Population (in %) of European Union in 1963 to that in 1969?
Your answer should be very brief. 1.01. What is the ratio of the Population (in %) of Namibia in 1963 to that in 1969?
Provide a succinct answer. 1.01. What is the ratio of the Population (in %) of Oman in 1963 to that in 1969?
Make the answer very short. 1.03. What is the ratio of the Population (in %) in Yemen, Rep. in 1963 to that in 1969?
Provide a succinct answer. 1.03. What is the ratio of the Population (in %) of Namibia in 1964 to that in 1966?
Your answer should be very brief. 1. What is the ratio of the Population (in %) of Oman in 1964 to that in 1966?
Keep it short and to the point. 1.01. What is the ratio of the Population (in %) in European Union in 1964 to that in 1967?
Offer a very short reply. 1. What is the ratio of the Population (in %) of Namibia in 1964 to that in 1967?
Give a very brief answer. 1.01. What is the ratio of the Population (in %) in Oman in 1964 to that in 1967?
Your answer should be very brief. 1.02. What is the ratio of the Population (in %) in Yemen, Rep. in 1964 to that in 1967?
Your answer should be compact. 1.01. What is the ratio of the Population (in %) of European Union in 1964 to that in 1968?
Keep it short and to the point. 1.01. What is the ratio of the Population (in %) of Namibia in 1964 to that in 1968?
Keep it short and to the point. 1.01. What is the ratio of the Population (in %) of Oman in 1964 to that in 1968?
Your answer should be compact. 1.02. What is the ratio of the Population (in %) in Yemen, Rep. in 1964 to that in 1968?
Provide a succinct answer. 1.02. What is the ratio of the Population (in %) of European Union in 1964 to that in 1969?
Your answer should be very brief. 1.01. What is the ratio of the Population (in %) in Namibia in 1964 to that in 1969?
Offer a very short reply. 1.01. What is the ratio of the Population (in %) of Oman in 1964 to that in 1969?
Your answer should be compact. 1.03. What is the ratio of the Population (in %) in Yemen, Rep. in 1964 to that in 1969?
Make the answer very short. 1.03. What is the ratio of the Population (in %) of Yemen, Rep. in 1965 to that in 1966?
Your answer should be compact. 1.01. What is the ratio of the Population (in %) of European Union in 1965 to that in 1967?
Ensure brevity in your answer.  1. What is the ratio of the Population (in %) of Oman in 1965 to that in 1967?
Ensure brevity in your answer.  1.01. What is the ratio of the Population (in %) in Yemen, Rep. in 1965 to that in 1967?
Ensure brevity in your answer.  1.01. What is the ratio of the Population (in %) in European Union in 1965 to that in 1968?
Give a very brief answer. 1.01. What is the ratio of the Population (in %) in Namibia in 1965 to that in 1968?
Offer a very short reply. 1.01. What is the ratio of the Population (in %) in Oman in 1965 to that in 1968?
Offer a terse response. 1.02. What is the ratio of the Population (in %) of Yemen, Rep. in 1965 to that in 1968?
Keep it short and to the point. 1.02. What is the ratio of the Population (in %) in European Union in 1965 to that in 1969?
Your answer should be compact. 1.01. What is the ratio of the Population (in %) of Namibia in 1965 to that in 1969?
Ensure brevity in your answer.  1.01. What is the ratio of the Population (in %) of Oman in 1965 to that in 1969?
Your answer should be compact. 1.02. What is the ratio of the Population (in %) in Yemen, Rep. in 1965 to that in 1969?
Your answer should be compact. 1.03. What is the ratio of the Population (in %) in European Union in 1966 to that in 1968?
Give a very brief answer. 1. What is the ratio of the Population (in %) in Namibia in 1966 to that in 1968?
Offer a very short reply. 1. What is the ratio of the Population (in %) of Oman in 1966 to that in 1968?
Keep it short and to the point. 1.01. What is the ratio of the Population (in %) of Yemen, Rep. in 1966 to that in 1968?
Provide a short and direct response. 1.02. What is the ratio of the Population (in %) in European Union in 1966 to that in 1969?
Ensure brevity in your answer.  1.01. What is the ratio of the Population (in %) of Oman in 1966 to that in 1969?
Keep it short and to the point. 1.02. What is the ratio of the Population (in %) in Yemen, Rep. in 1966 to that in 1969?
Offer a terse response. 1.03. What is the ratio of the Population (in %) of European Union in 1967 to that in 1968?
Provide a succinct answer. 1. What is the ratio of the Population (in %) of Oman in 1967 to that in 1968?
Keep it short and to the point. 1.01. What is the ratio of the Population (in %) of Yemen, Rep. in 1967 to that in 1968?
Provide a short and direct response. 1.01. What is the ratio of the Population (in %) of European Union in 1967 to that in 1969?
Ensure brevity in your answer.  1. What is the ratio of the Population (in %) in Namibia in 1967 to that in 1969?
Offer a very short reply. 1. What is the ratio of the Population (in %) in Oman in 1967 to that in 1969?
Your response must be concise. 1.01. What is the ratio of the Population (in %) of Yemen, Rep. in 1967 to that in 1969?
Your response must be concise. 1.02. What is the ratio of the Population (in %) in European Union in 1968 to that in 1969?
Offer a terse response. 1. What is the ratio of the Population (in %) in Yemen, Rep. in 1968 to that in 1969?
Ensure brevity in your answer.  1.01. What is the difference between the highest and the second highest Population (in %) in European Union?
Provide a short and direct response. 0.03. What is the difference between the highest and the second highest Population (in %) of Namibia?
Make the answer very short. 0.16. What is the difference between the highest and the second highest Population (in %) of Oman?
Offer a terse response. 0.27. What is the difference between the highest and the second highest Population (in %) of Yemen, Rep.?
Ensure brevity in your answer.  0.1. What is the difference between the highest and the lowest Population (in %) in European Union?
Make the answer very short. 0.58. What is the difference between the highest and the lowest Population (in %) in Namibia?
Ensure brevity in your answer.  0.84. What is the difference between the highest and the lowest Population (in %) in Oman?
Make the answer very short. 1.93. What is the difference between the highest and the lowest Population (in %) in Yemen, Rep.?
Give a very brief answer. 1.69. 